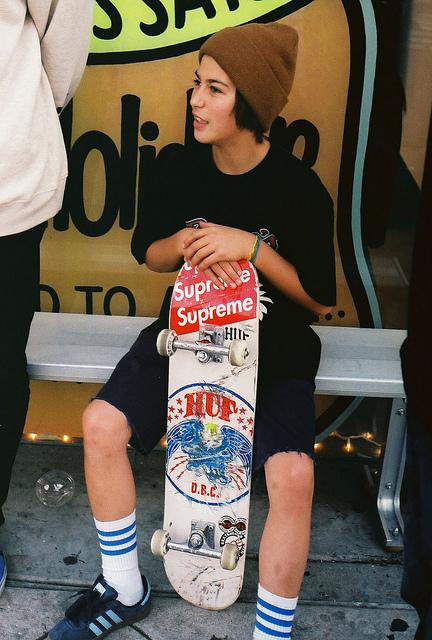What brand are the shoes?
Quick response, please. Adidas. What is the boy sitting on?
Answer briefly. Bench. What is the boy holding?
Quick response, please. Skateboard. 